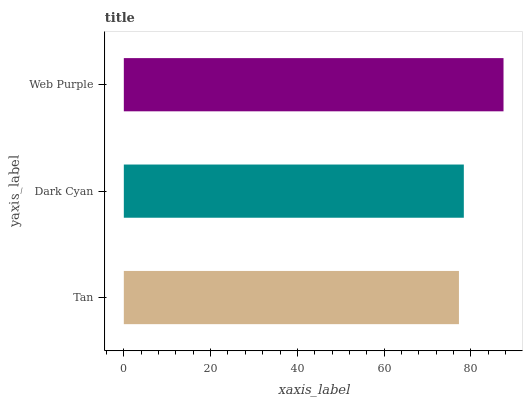Is Tan the minimum?
Answer yes or no. Yes. Is Web Purple the maximum?
Answer yes or no. Yes. Is Dark Cyan the minimum?
Answer yes or no. No. Is Dark Cyan the maximum?
Answer yes or no. No. Is Dark Cyan greater than Tan?
Answer yes or no. Yes. Is Tan less than Dark Cyan?
Answer yes or no. Yes. Is Tan greater than Dark Cyan?
Answer yes or no. No. Is Dark Cyan less than Tan?
Answer yes or no. No. Is Dark Cyan the high median?
Answer yes or no. Yes. Is Dark Cyan the low median?
Answer yes or no. Yes. Is Web Purple the high median?
Answer yes or no. No. Is Web Purple the low median?
Answer yes or no. No. 